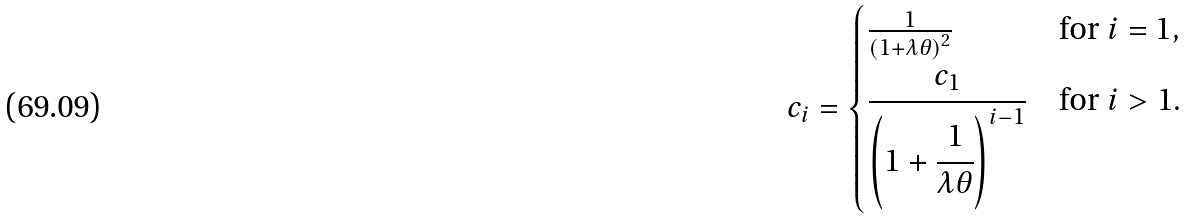<formula> <loc_0><loc_0><loc_500><loc_500>c _ { i } = \begin{cases} \frac { 1 } { \left ( 1 + \lambda \theta \right ) ^ { 2 } } & \text {for $i=1$} , \\ \cfrac { c _ { 1 } } { \left ( 1 + \cfrac { 1 } { \lambda \theta } \right ) ^ { i - 1 } } & \text {for $i>1$} . \end{cases}</formula> 